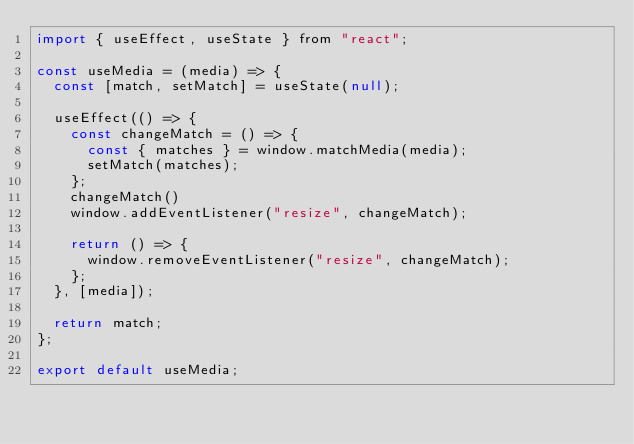Convert code to text. <code><loc_0><loc_0><loc_500><loc_500><_JavaScript_>import { useEffect, useState } from "react";

const useMedia = (media) => {
  const [match, setMatch] = useState(null);

  useEffect(() => {
    const changeMatch = () => {
      const { matches } = window.matchMedia(media);
      setMatch(matches);
    };
    changeMatch()
    window.addEventListener("resize", changeMatch);

    return () => {
      window.removeEventListener("resize", changeMatch);
    };
  }, [media]);

  return match;
};

export default useMedia;
</code> 